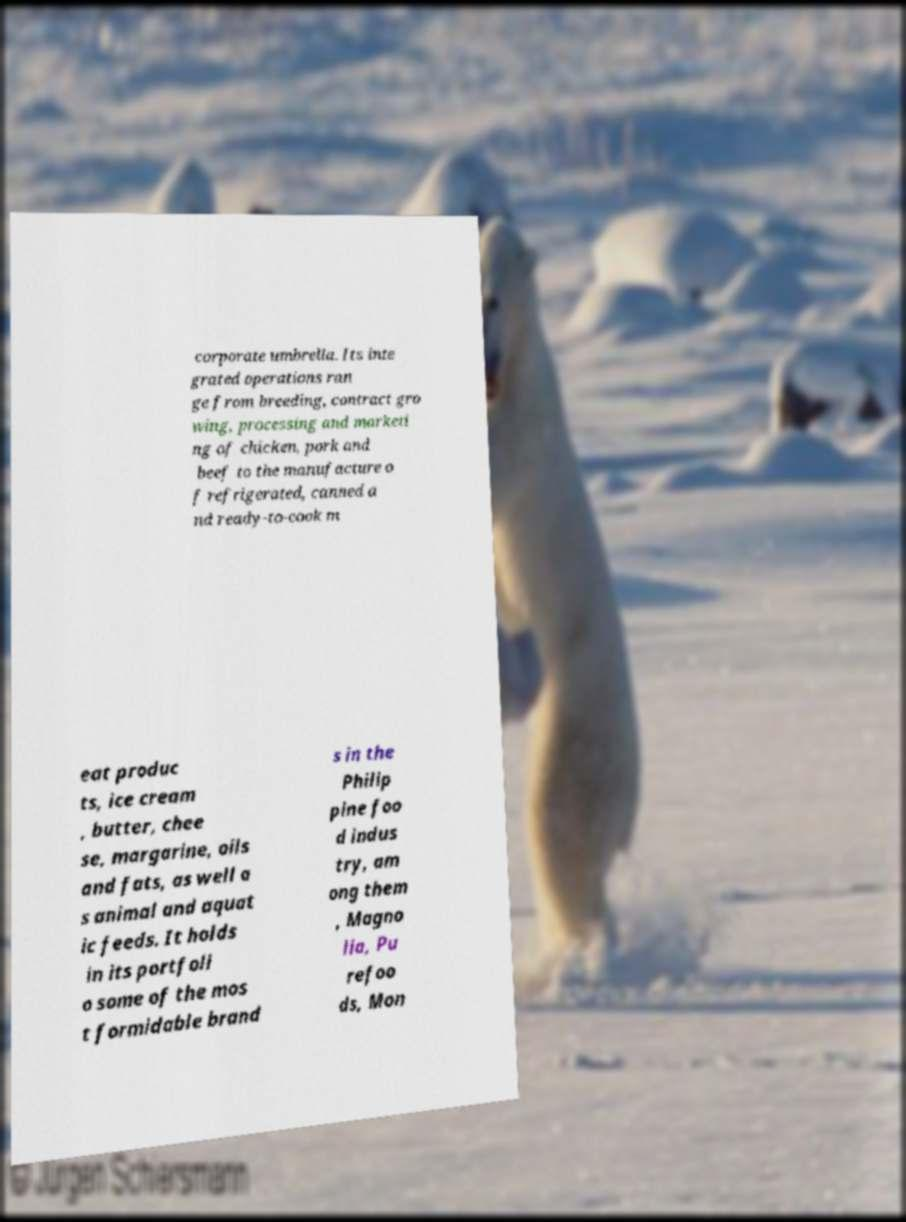I need the written content from this picture converted into text. Can you do that? corporate umbrella. Its inte grated operations ran ge from breeding, contract gro wing, processing and marketi ng of chicken, pork and beef to the manufacture o f refrigerated, canned a nd ready-to-cook m eat produc ts, ice cream , butter, chee se, margarine, oils and fats, as well a s animal and aquat ic feeds. It holds in its portfoli o some of the mos t formidable brand s in the Philip pine foo d indus try, am ong them , Magno lia, Pu refoo ds, Mon 